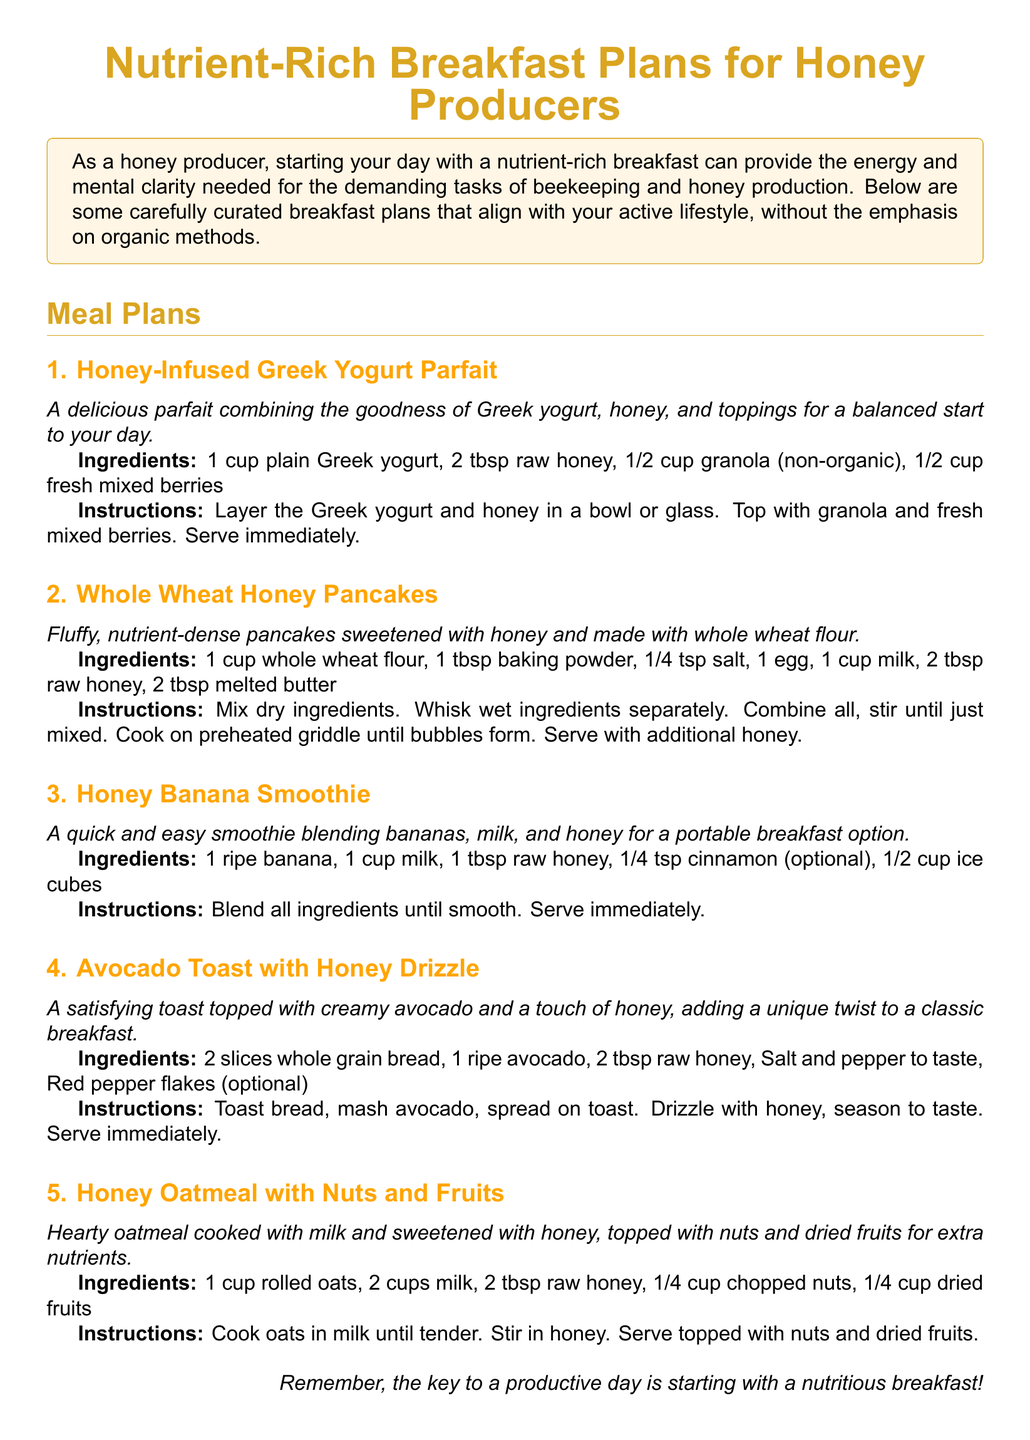What is the title of the document? The title is presented at the beginning of the document, summarizing the content focus.
Answer: Nutrient-Rich Breakfast Plans for Honey Producers How many breakfast plans are listed? The document explicitly states the number of meal plans included.
Answer: 5 What ingredient is common in all breakfast plans? The ingredient that is consistently referenced across all meal plans is used in each recipe providing a similar flavor profile.
Answer: Honey What is the first breakfast plan mentioned? The first meal plan is highlighted as the opening recipe in the document.
Answer: Honey-Infused Greek Yogurt Parfait Which breakfast plan includes oats? The plan that features oats is identified based on the ingredients specified in the recipe section.
Answer: Honey Oatmeal with Nuts and Fruits How many tablespoons of raw honey are used in the Whole Wheat Honey Pancakes? The exact measurement of raw honey is stated in the ingredient list of this particular breakfast plan.
Answer: 2 tbsp What is a key benefit of the breakfast plans? The document mentions a specific advantage that these breakfast plans provide to honey producers.
Answer: Energy and mental clarity What type of document is this? The format and content designate this document as a specific type of informational guide.
Answer: Meal plan 